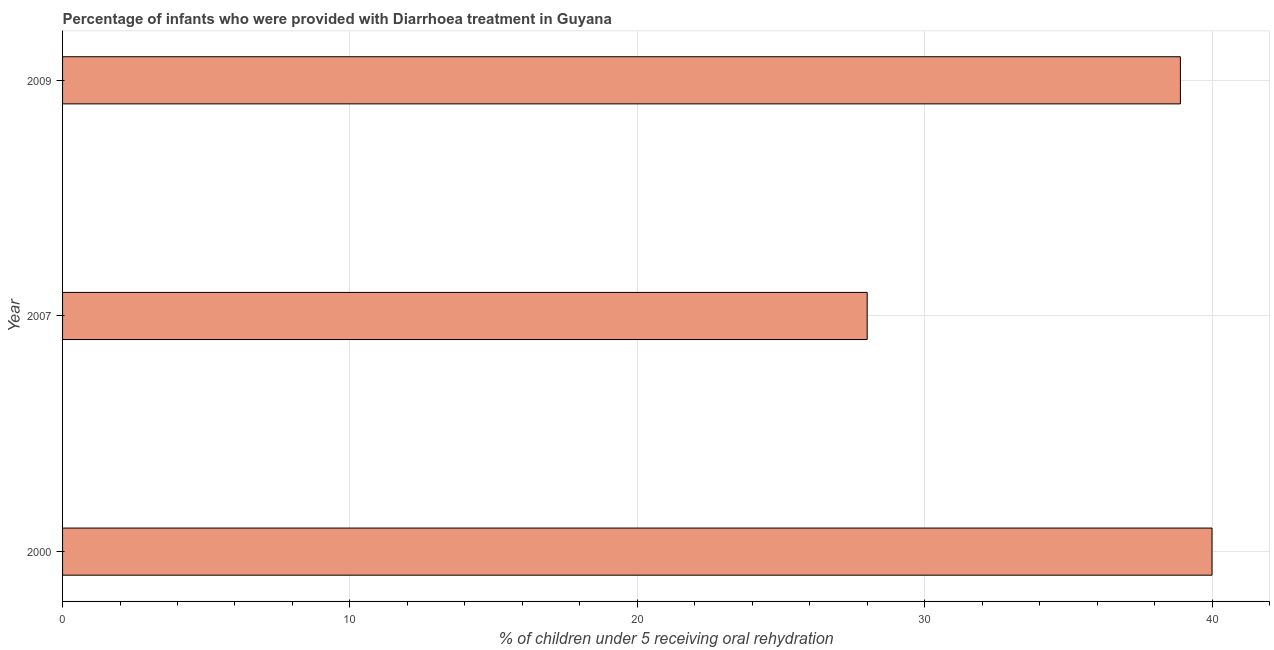What is the title of the graph?
Provide a succinct answer. Percentage of infants who were provided with Diarrhoea treatment in Guyana. What is the label or title of the X-axis?
Your answer should be very brief. % of children under 5 receiving oral rehydration. Across all years, what is the maximum percentage of children who were provided with treatment diarrhoea?
Your answer should be compact. 40. Across all years, what is the minimum percentage of children who were provided with treatment diarrhoea?
Keep it short and to the point. 28. What is the sum of the percentage of children who were provided with treatment diarrhoea?
Make the answer very short. 106.9. What is the average percentage of children who were provided with treatment diarrhoea per year?
Give a very brief answer. 35.63. What is the median percentage of children who were provided with treatment diarrhoea?
Provide a succinct answer. 38.9. In how many years, is the percentage of children who were provided with treatment diarrhoea greater than 4 %?
Give a very brief answer. 3. What is the ratio of the percentage of children who were provided with treatment diarrhoea in 2000 to that in 2009?
Make the answer very short. 1.03. Is the percentage of children who were provided with treatment diarrhoea in 2007 less than that in 2009?
Your answer should be very brief. Yes. What is the difference between the highest and the second highest percentage of children who were provided with treatment diarrhoea?
Your response must be concise. 1.1. Is the sum of the percentage of children who were provided with treatment diarrhoea in 2000 and 2007 greater than the maximum percentage of children who were provided with treatment diarrhoea across all years?
Your response must be concise. Yes. What is the difference between the highest and the lowest percentage of children who were provided with treatment diarrhoea?
Provide a succinct answer. 12. Are all the bars in the graph horizontal?
Offer a terse response. Yes. How many years are there in the graph?
Make the answer very short. 3. What is the difference between two consecutive major ticks on the X-axis?
Keep it short and to the point. 10. What is the % of children under 5 receiving oral rehydration in 2000?
Provide a short and direct response. 40. What is the % of children under 5 receiving oral rehydration in 2007?
Keep it short and to the point. 28. What is the % of children under 5 receiving oral rehydration in 2009?
Offer a very short reply. 38.9. What is the difference between the % of children under 5 receiving oral rehydration in 2000 and 2007?
Provide a succinct answer. 12. What is the difference between the % of children under 5 receiving oral rehydration in 2000 and 2009?
Provide a succinct answer. 1.1. What is the ratio of the % of children under 5 receiving oral rehydration in 2000 to that in 2007?
Offer a very short reply. 1.43. What is the ratio of the % of children under 5 receiving oral rehydration in 2000 to that in 2009?
Keep it short and to the point. 1.03. What is the ratio of the % of children under 5 receiving oral rehydration in 2007 to that in 2009?
Keep it short and to the point. 0.72. 